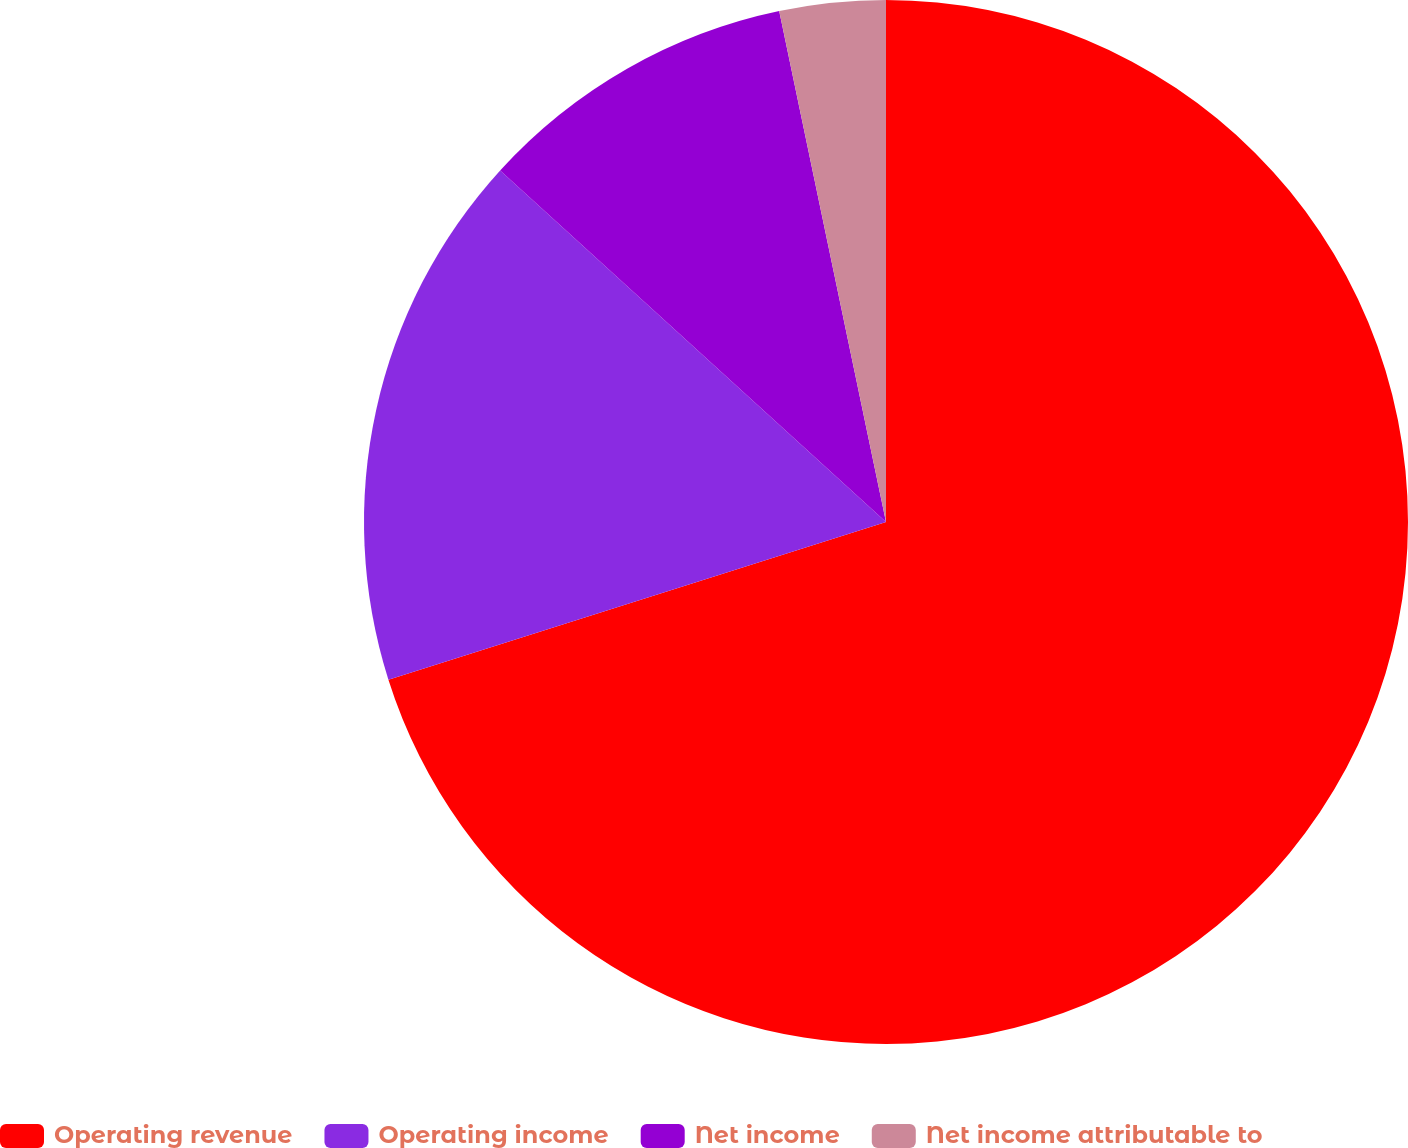<chart> <loc_0><loc_0><loc_500><loc_500><pie_chart><fcel>Operating revenue<fcel>Operating income<fcel>Net income<fcel>Net income attributable to<nl><fcel>70.12%<fcel>16.65%<fcel>9.96%<fcel>3.28%<nl></chart> 